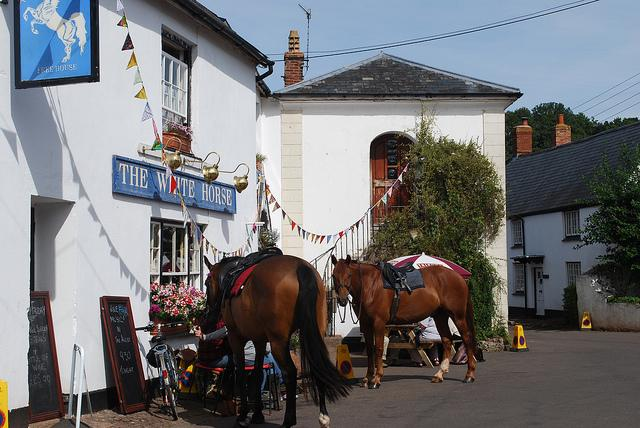What type of movie would this scene appear in? Please explain your reasoning. western. Westerns are known for having horses and there are two horses outside of the building. 